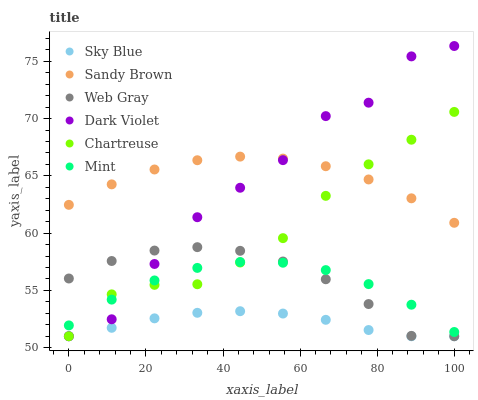Does Sky Blue have the minimum area under the curve?
Answer yes or no. Yes. Does Sandy Brown have the maximum area under the curve?
Answer yes or no. Yes. Does Mint have the minimum area under the curve?
Answer yes or no. No. Does Mint have the maximum area under the curve?
Answer yes or no. No. Is Sky Blue the smoothest?
Answer yes or no. Yes. Is Dark Violet the roughest?
Answer yes or no. Yes. Is Mint the smoothest?
Answer yes or no. No. Is Mint the roughest?
Answer yes or no. No. Does Web Gray have the lowest value?
Answer yes or no. Yes. Does Mint have the lowest value?
Answer yes or no. No. Does Dark Violet have the highest value?
Answer yes or no. Yes. Does Mint have the highest value?
Answer yes or no. No. Is Mint less than Sandy Brown?
Answer yes or no. Yes. Is Mint greater than Sky Blue?
Answer yes or no. Yes. Does Dark Violet intersect Chartreuse?
Answer yes or no. Yes. Is Dark Violet less than Chartreuse?
Answer yes or no. No. Is Dark Violet greater than Chartreuse?
Answer yes or no. No. Does Mint intersect Sandy Brown?
Answer yes or no. No. 